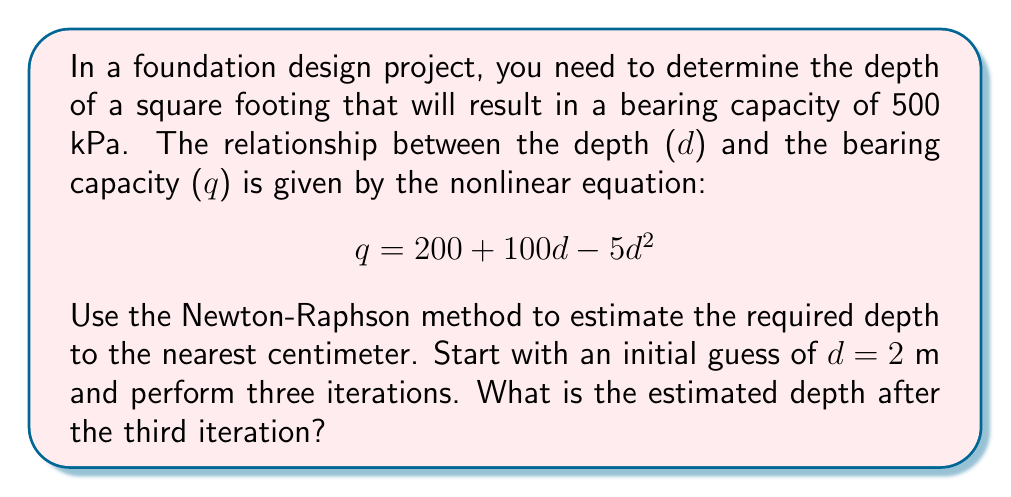Teach me how to tackle this problem. To solve this problem using the Newton-Raphson method, we follow these steps:

1) First, we rearrange the equation to get f(d) = 0:
   $$f(d) = 200 + 100d - 5d^2 - 500 = 0$$

2) We need to find the derivative of f(d):
   $$f'(d) = 100 - 10d$$

3) The Newton-Raphson formula is:
   $$d_{n+1} = d_n - \frac{f(d_n)}{f'(d_n)}$$

4) Let's perform three iterations:

   Iteration 1:
   $$f(2) = 200 + 100(2) - 5(2)^2 - 500 = -80$$
   $$f'(2) = 100 - 10(2) = 80$$
   $$d_1 = 2 - \frac{-80}{80} = 3 \text{ m}$$

   Iteration 2:
   $$f(3) = 200 + 100(3) - 5(3)^2 - 500 = 55$$
   $$f'(3) = 100 - 10(3) = 70$$
   $$d_2 = 3 - \frac{55}{70} = 2.2143 \text{ m}$$

   Iteration 3:
   $$f(2.2143) = 200 + 100(2.2143) - 5(2.2143)^2 - 500 = -0.2041$$
   $$f'(2.2143) = 100 - 10(2.2143) = 77.857$$
   $$d_3 = 2.2143 - \frac{-0.2041}{77.857} = 2.2169 \text{ m}$$

5) Rounding to the nearest centimeter, we get 2.22 m.
Answer: 2.22 m 